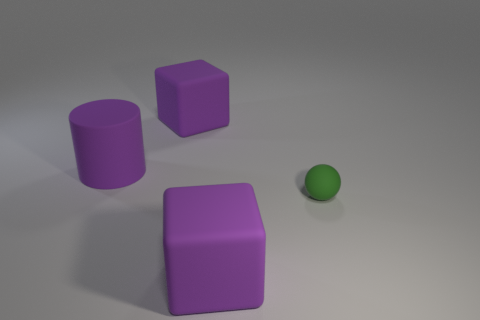Add 2 tiny spheres. How many objects exist? 6 Subtract 1 spheres. How many spheres are left? 0 Subtract all green blocks. Subtract all gray cylinders. How many blocks are left? 2 Subtract all purple rubber things. Subtract all small purple matte cylinders. How many objects are left? 1 Add 4 purple things. How many purple things are left? 7 Add 4 big rubber blocks. How many big rubber blocks exist? 6 Subtract 0 brown cubes. How many objects are left? 4 Subtract all balls. How many objects are left? 3 